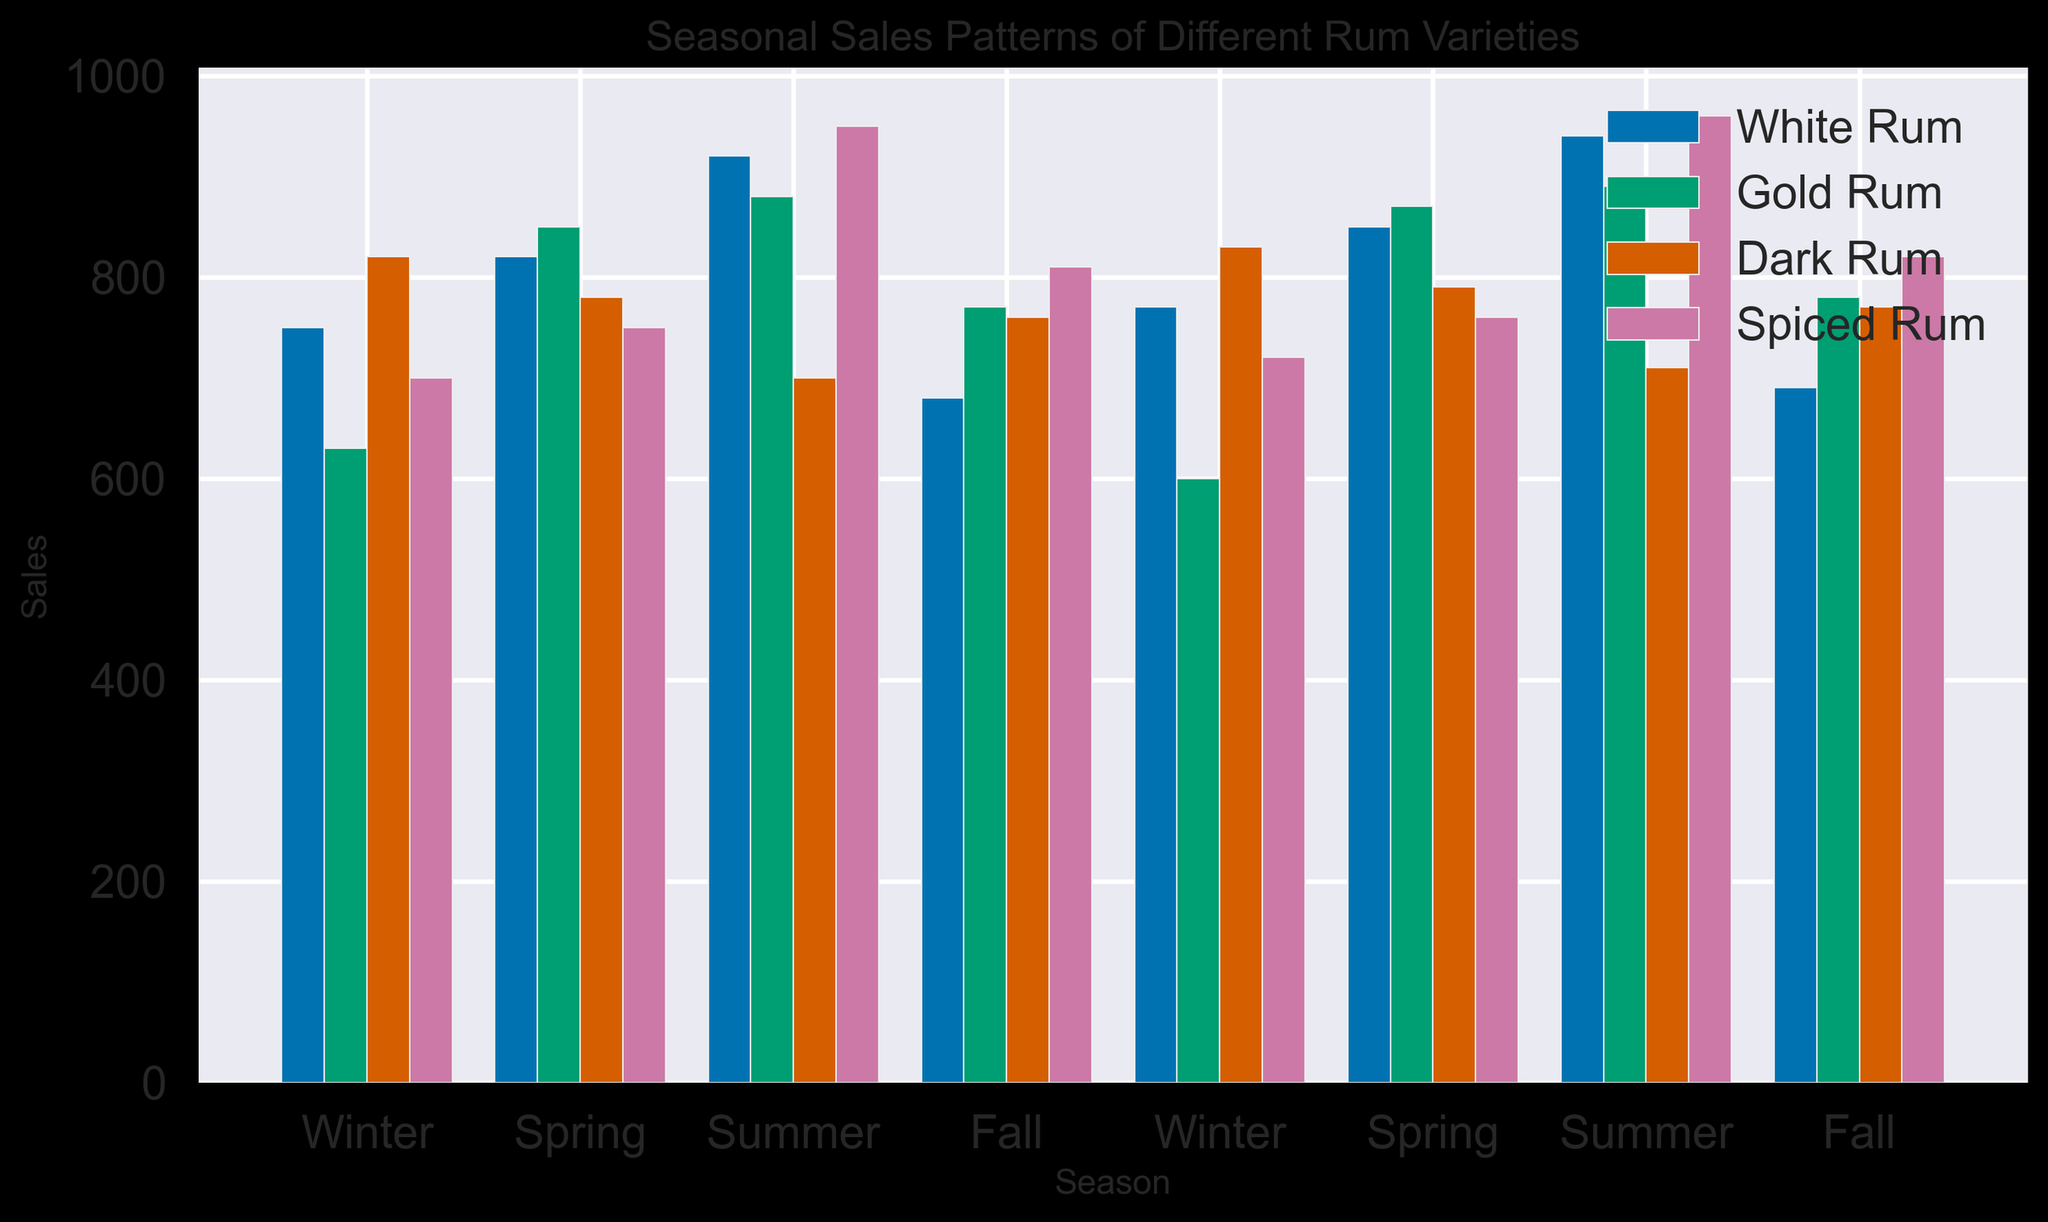What's the total sales of White Rum in Summer? Refer to the Summer sales for White Rum in both yearly entries: 920 and 940. Sum these values to get the total sales. 920 + 940 = 1860
Answer: 1860 Which rum variety had the highest sales in Winter? Check the Winter sales data for each rum variety. The highest values in Winter are: White Rum (750, 770), Gold Rum (630, 600), Dark Rum (820, 830), and Spiced Rum (700, 720). Dark Rum has the highest value, 830.
Answer: Dark Rum Does Spiced Rum or Gold Rum have higher sales in Fall? Compare the Fall sales data for Spiced Rum (810, 820) and Gold Rum (770, 780). Spiced Rum has higher sales in both years.
Answer: Spiced Rum What is the average sales of Dark Rum in Spring? Find the sales of Dark Rum in Spring: 780 and 790. Average these values: (780 + 790) / 2 = 785
Answer: 785 How much more were the sales of Spiced Rum compared to Dark Rum in Summer? Compare the Summer sales for Spiced Rum (950, 960) and Dark Rum (700, 710). Calculate the difference: (960 + 950) - (700 + 710) = 1910 - 1410 = 500
Answer: 500 Which season had the lowest sales for White Rum? Check the sales of White Rum across all seasons: Winter (750, 770), Spring (820, 850), Summer (920, 940), Fall (680, 690). The lowest sales are in Fall.
Answer: Fall By how much did Gold Rum sales in Spring increase from the previous Fall? Find Gold Rum sales in Fall and the following Spring: Fall (770, 780) and Spring (850, 870). Calculate the increase from Fall 770 to Spring 850: 850 - 770 = 80. Do the same for the next year, from Fall 780 to Spring 870: 870 - 780 = 90. Finally, sum the increases: 80 + 90 = 170.
Answer: 170 